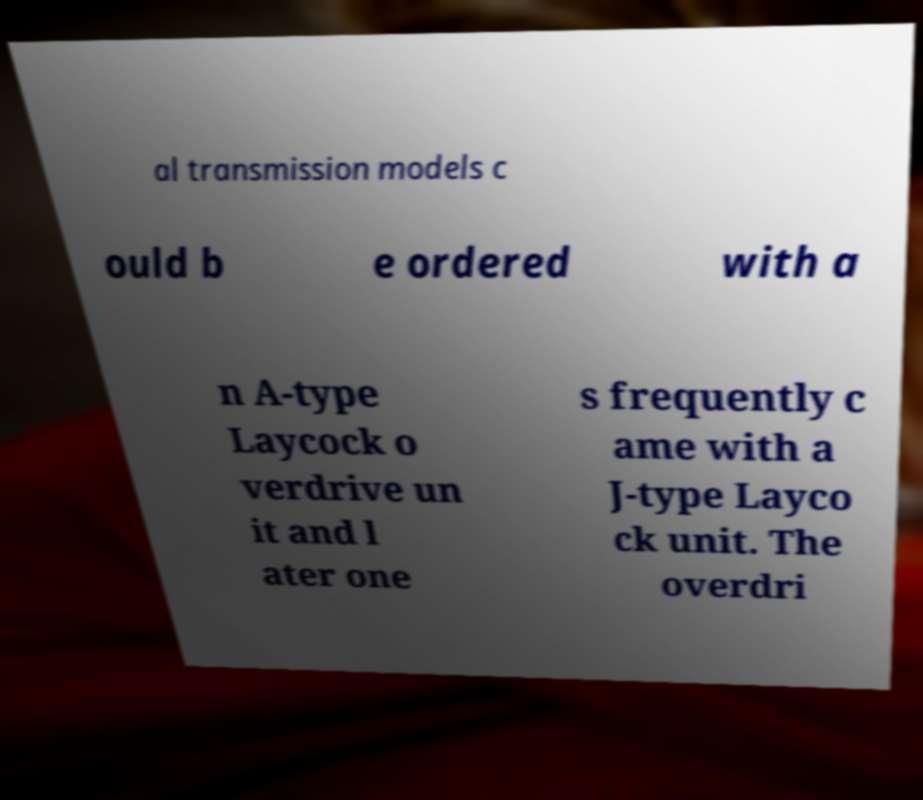What messages or text are displayed in this image? I need them in a readable, typed format. al transmission models c ould b e ordered with a n A-type Laycock o verdrive un it and l ater one s frequently c ame with a J-type Layco ck unit. The overdri 